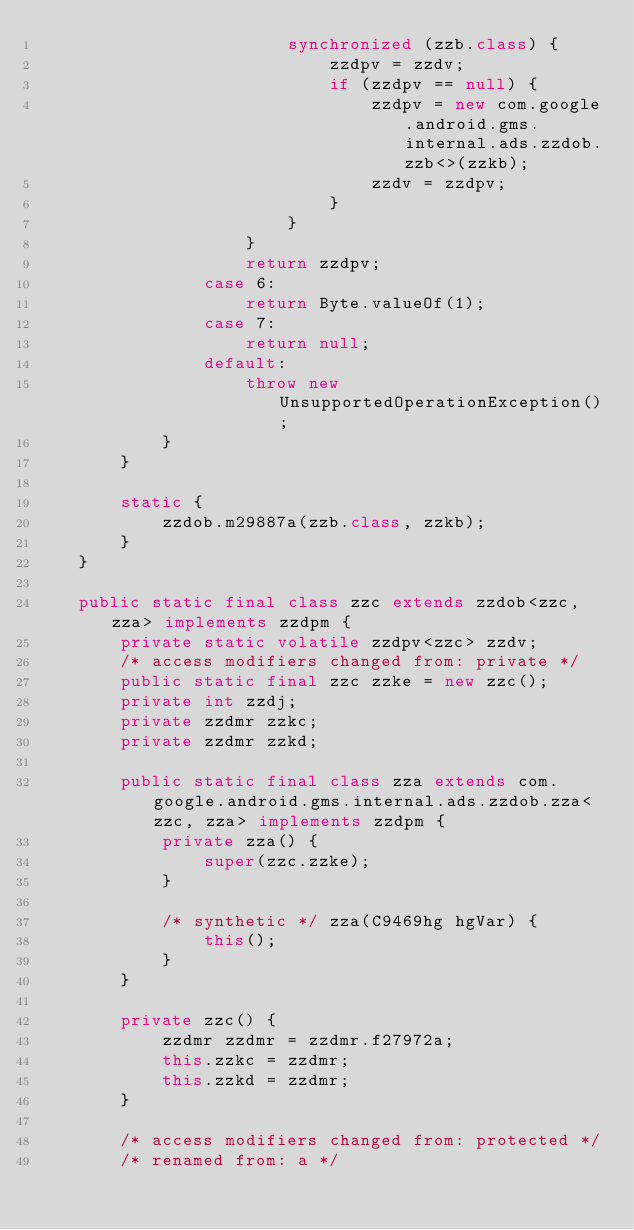<code> <loc_0><loc_0><loc_500><loc_500><_Java_>                        synchronized (zzb.class) {
                            zzdpv = zzdv;
                            if (zzdpv == null) {
                                zzdpv = new com.google.android.gms.internal.ads.zzdob.zzb<>(zzkb);
                                zzdv = zzdpv;
                            }
                        }
                    }
                    return zzdpv;
                case 6:
                    return Byte.valueOf(1);
                case 7:
                    return null;
                default:
                    throw new UnsupportedOperationException();
            }
        }

        static {
            zzdob.m29887a(zzb.class, zzkb);
        }
    }

    public static final class zzc extends zzdob<zzc, zza> implements zzdpm {
        private static volatile zzdpv<zzc> zzdv;
        /* access modifiers changed from: private */
        public static final zzc zzke = new zzc();
        private int zzdj;
        private zzdmr zzkc;
        private zzdmr zzkd;

        public static final class zza extends com.google.android.gms.internal.ads.zzdob.zza<zzc, zza> implements zzdpm {
            private zza() {
                super(zzc.zzke);
            }

            /* synthetic */ zza(C9469hg hgVar) {
                this();
            }
        }

        private zzc() {
            zzdmr zzdmr = zzdmr.f27972a;
            this.zzkc = zzdmr;
            this.zzkd = zzdmr;
        }

        /* access modifiers changed from: protected */
        /* renamed from: a */</code> 